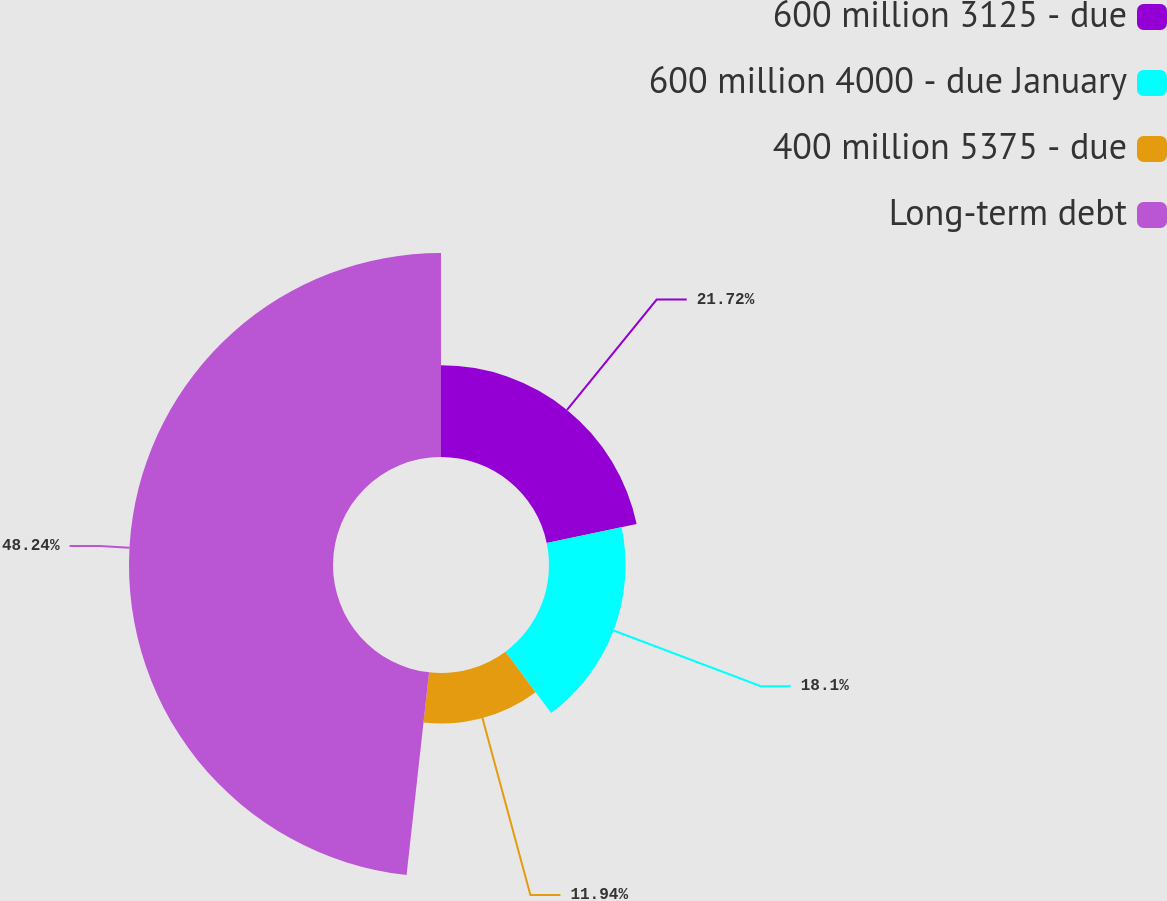<chart> <loc_0><loc_0><loc_500><loc_500><pie_chart><fcel>600 million 3125 - due<fcel>600 million 4000 - due January<fcel>400 million 5375 - due<fcel>Long-term debt<nl><fcel>21.72%<fcel>18.1%<fcel>11.94%<fcel>48.24%<nl></chart> 